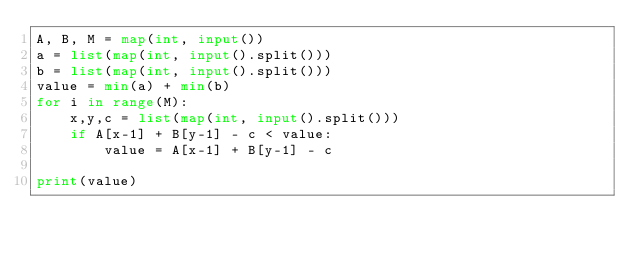<code> <loc_0><loc_0><loc_500><loc_500><_Python_>A, B, M = map(int, input())
a = list(map(int, input().split()))
b = list(map(int, input().split()))
value = min(a) + min(b)
for i in range(M):
    x,y,c = list(map(int, input().split()))
    if A[x-1] + B[y-1] - c < value:
        value = A[x-1] + B[y-1] - c

print(value)
</code> 